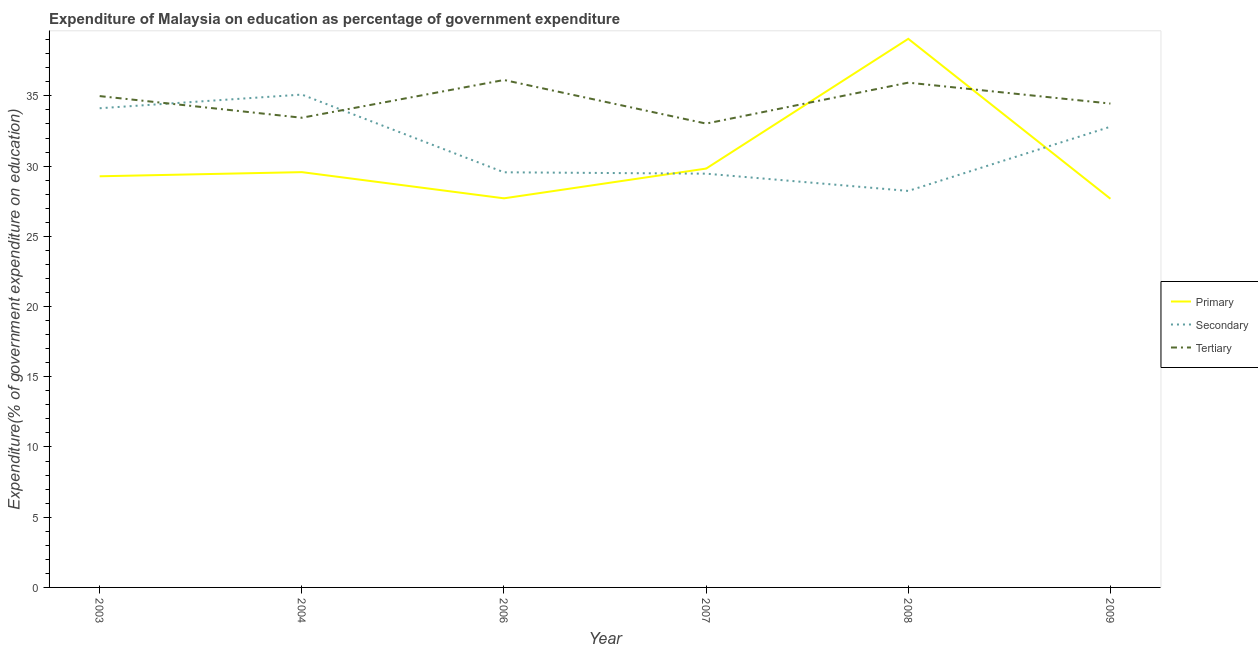Is the number of lines equal to the number of legend labels?
Give a very brief answer. Yes. What is the expenditure on secondary education in 2008?
Provide a short and direct response. 28.23. Across all years, what is the maximum expenditure on tertiary education?
Your answer should be very brief. 36.13. Across all years, what is the minimum expenditure on tertiary education?
Your answer should be compact. 33.03. In which year was the expenditure on tertiary education maximum?
Offer a very short reply. 2006. In which year was the expenditure on secondary education minimum?
Offer a terse response. 2008. What is the total expenditure on tertiary education in the graph?
Make the answer very short. 207.99. What is the difference between the expenditure on primary education in 2004 and that in 2007?
Your response must be concise. -0.25. What is the difference between the expenditure on tertiary education in 2007 and the expenditure on secondary education in 2009?
Offer a very short reply. 0.22. What is the average expenditure on primary education per year?
Keep it short and to the point. 30.52. In the year 2008, what is the difference between the expenditure on primary education and expenditure on secondary education?
Provide a succinct answer. 10.83. In how many years, is the expenditure on secondary education greater than 8 %?
Your response must be concise. 6. What is the ratio of the expenditure on tertiary education in 2003 to that in 2006?
Keep it short and to the point. 0.97. Is the expenditure on tertiary education in 2003 less than that in 2006?
Provide a short and direct response. Yes. Is the difference between the expenditure on tertiary education in 2007 and 2009 greater than the difference between the expenditure on secondary education in 2007 and 2009?
Keep it short and to the point. Yes. What is the difference between the highest and the second highest expenditure on tertiary education?
Provide a short and direct response. 0.19. What is the difference between the highest and the lowest expenditure on secondary education?
Give a very brief answer. 6.86. In how many years, is the expenditure on primary education greater than the average expenditure on primary education taken over all years?
Your answer should be very brief. 1. Is it the case that in every year, the sum of the expenditure on primary education and expenditure on secondary education is greater than the expenditure on tertiary education?
Ensure brevity in your answer.  Yes. Does the expenditure on primary education monotonically increase over the years?
Your answer should be very brief. No. Is the expenditure on primary education strictly less than the expenditure on secondary education over the years?
Give a very brief answer. No. Are the values on the major ticks of Y-axis written in scientific E-notation?
Make the answer very short. No. Does the graph contain any zero values?
Provide a succinct answer. No. Where does the legend appear in the graph?
Ensure brevity in your answer.  Center right. How are the legend labels stacked?
Provide a succinct answer. Vertical. What is the title of the graph?
Your answer should be very brief. Expenditure of Malaysia on education as percentage of government expenditure. What is the label or title of the X-axis?
Keep it short and to the point. Year. What is the label or title of the Y-axis?
Offer a very short reply. Expenditure(% of government expenditure on education). What is the Expenditure(% of government expenditure on education) in Primary in 2003?
Your answer should be very brief. 29.28. What is the Expenditure(% of government expenditure on education) in Secondary in 2003?
Ensure brevity in your answer.  34.12. What is the Expenditure(% of government expenditure on education) of Tertiary in 2003?
Your response must be concise. 34.99. What is the Expenditure(% of government expenditure on education) in Primary in 2004?
Make the answer very short. 29.57. What is the Expenditure(% of government expenditure on education) in Secondary in 2004?
Provide a succinct answer. 35.09. What is the Expenditure(% of government expenditure on education) in Tertiary in 2004?
Offer a very short reply. 33.45. What is the Expenditure(% of government expenditure on education) of Primary in 2006?
Ensure brevity in your answer.  27.71. What is the Expenditure(% of government expenditure on education) of Secondary in 2006?
Offer a terse response. 29.56. What is the Expenditure(% of government expenditure on education) of Tertiary in 2006?
Provide a succinct answer. 36.13. What is the Expenditure(% of government expenditure on education) of Primary in 2007?
Your response must be concise. 29.82. What is the Expenditure(% of government expenditure on education) in Secondary in 2007?
Your answer should be compact. 29.46. What is the Expenditure(% of government expenditure on education) of Tertiary in 2007?
Your answer should be very brief. 33.03. What is the Expenditure(% of government expenditure on education) in Primary in 2008?
Ensure brevity in your answer.  39.06. What is the Expenditure(% of government expenditure on education) of Secondary in 2008?
Provide a succinct answer. 28.23. What is the Expenditure(% of government expenditure on education) in Tertiary in 2008?
Give a very brief answer. 35.94. What is the Expenditure(% of government expenditure on education) of Primary in 2009?
Provide a short and direct response. 27.68. What is the Expenditure(% of government expenditure on education) of Secondary in 2009?
Your answer should be very brief. 32.81. What is the Expenditure(% of government expenditure on education) in Tertiary in 2009?
Offer a very short reply. 34.45. Across all years, what is the maximum Expenditure(% of government expenditure on education) in Primary?
Your answer should be compact. 39.06. Across all years, what is the maximum Expenditure(% of government expenditure on education) of Secondary?
Your answer should be compact. 35.09. Across all years, what is the maximum Expenditure(% of government expenditure on education) in Tertiary?
Provide a succinct answer. 36.13. Across all years, what is the minimum Expenditure(% of government expenditure on education) in Primary?
Provide a succinct answer. 27.68. Across all years, what is the minimum Expenditure(% of government expenditure on education) of Secondary?
Your response must be concise. 28.23. Across all years, what is the minimum Expenditure(% of government expenditure on education) in Tertiary?
Offer a very short reply. 33.03. What is the total Expenditure(% of government expenditure on education) of Primary in the graph?
Offer a terse response. 183.12. What is the total Expenditure(% of government expenditure on education) of Secondary in the graph?
Give a very brief answer. 189.28. What is the total Expenditure(% of government expenditure on education) in Tertiary in the graph?
Provide a succinct answer. 207.99. What is the difference between the Expenditure(% of government expenditure on education) of Primary in 2003 and that in 2004?
Provide a short and direct response. -0.3. What is the difference between the Expenditure(% of government expenditure on education) of Secondary in 2003 and that in 2004?
Your response must be concise. -0.97. What is the difference between the Expenditure(% of government expenditure on education) of Tertiary in 2003 and that in 2004?
Provide a short and direct response. 1.54. What is the difference between the Expenditure(% of government expenditure on education) of Primary in 2003 and that in 2006?
Your response must be concise. 1.57. What is the difference between the Expenditure(% of government expenditure on education) in Secondary in 2003 and that in 2006?
Offer a terse response. 4.56. What is the difference between the Expenditure(% of government expenditure on education) of Tertiary in 2003 and that in 2006?
Provide a short and direct response. -1.15. What is the difference between the Expenditure(% of government expenditure on education) of Primary in 2003 and that in 2007?
Make the answer very short. -0.55. What is the difference between the Expenditure(% of government expenditure on education) in Secondary in 2003 and that in 2007?
Offer a terse response. 4.66. What is the difference between the Expenditure(% of government expenditure on education) of Tertiary in 2003 and that in 2007?
Give a very brief answer. 1.96. What is the difference between the Expenditure(% of government expenditure on education) in Primary in 2003 and that in 2008?
Offer a terse response. -9.79. What is the difference between the Expenditure(% of government expenditure on education) in Secondary in 2003 and that in 2008?
Give a very brief answer. 5.89. What is the difference between the Expenditure(% of government expenditure on education) in Tertiary in 2003 and that in 2008?
Offer a terse response. -0.96. What is the difference between the Expenditure(% of government expenditure on education) in Primary in 2003 and that in 2009?
Ensure brevity in your answer.  1.6. What is the difference between the Expenditure(% of government expenditure on education) in Secondary in 2003 and that in 2009?
Ensure brevity in your answer.  1.32. What is the difference between the Expenditure(% of government expenditure on education) in Tertiary in 2003 and that in 2009?
Provide a succinct answer. 0.53. What is the difference between the Expenditure(% of government expenditure on education) of Primary in 2004 and that in 2006?
Offer a terse response. 1.86. What is the difference between the Expenditure(% of government expenditure on education) in Secondary in 2004 and that in 2006?
Make the answer very short. 5.53. What is the difference between the Expenditure(% of government expenditure on education) of Tertiary in 2004 and that in 2006?
Provide a succinct answer. -2.69. What is the difference between the Expenditure(% of government expenditure on education) in Primary in 2004 and that in 2007?
Make the answer very short. -0.25. What is the difference between the Expenditure(% of government expenditure on education) in Secondary in 2004 and that in 2007?
Offer a very short reply. 5.63. What is the difference between the Expenditure(% of government expenditure on education) of Tertiary in 2004 and that in 2007?
Give a very brief answer. 0.42. What is the difference between the Expenditure(% of government expenditure on education) of Primary in 2004 and that in 2008?
Give a very brief answer. -9.49. What is the difference between the Expenditure(% of government expenditure on education) of Secondary in 2004 and that in 2008?
Offer a terse response. 6.86. What is the difference between the Expenditure(% of government expenditure on education) in Tertiary in 2004 and that in 2008?
Offer a very short reply. -2.5. What is the difference between the Expenditure(% of government expenditure on education) of Primary in 2004 and that in 2009?
Make the answer very short. 1.9. What is the difference between the Expenditure(% of government expenditure on education) in Secondary in 2004 and that in 2009?
Provide a short and direct response. 2.29. What is the difference between the Expenditure(% of government expenditure on education) of Tertiary in 2004 and that in 2009?
Make the answer very short. -1.01. What is the difference between the Expenditure(% of government expenditure on education) of Primary in 2006 and that in 2007?
Give a very brief answer. -2.12. What is the difference between the Expenditure(% of government expenditure on education) of Secondary in 2006 and that in 2007?
Your answer should be compact. 0.1. What is the difference between the Expenditure(% of government expenditure on education) in Tertiary in 2006 and that in 2007?
Make the answer very short. 3.1. What is the difference between the Expenditure(% of government expenditure on education) of Primary in 2006 and that in 2008?
Provide a short and direct response. -11.36. What is the difference between the Expenditure(% of government expenditure on education) in Secondary in 2006 and that in 2008?
Provide a short and direct response. 1.33. What is the difference between the Expenditure(% of government expenditure on education) of Tertiary in 2006 and that in 2008?
Ensure brevity in your answer.  0.19. What is the difference between the Expenditure(% of government expenditure on education) of Primary in 2006 and that in 2009?
Your response must be concise. 0.03. What is the difference between the Expenditure(% of government expenditure on education) in Secondary in 2006 and that in 2009?
Your answer should be very brief. -3.25. What is the difference between the Expenditure(% of government expenditure on education) of Tertiary in 2006 and that in 2009?
Provide a short and direct response. 1.68. What is the difference between the Expenditure(% of government expenditure on education) in Primary in 2007 and that in 2008?
Keep it short and to the point. -9.24. What is the difference between the Expenditure(% of government expenditure on education) in Secondary in 2007 and that in 2008?
Ensure brevity in your answer.  1.23. What is the difference between the Expenditure(% of government expenditure on education) in Tertiary in 2007 and that in 2008?
Make the answer very short. -2.92. What is the difference between the Expenditure(% of government expenditure on education) in Primary in 2007 and that in 2009?
Keep it short and to the point. 2.15. What is the difference between the Expenditure(% of government expenditure on education) in Secondary in 2007 and that in 2009?
Provide a short and direct response. -3.34. What is the difference between the Expenditure(% of government expenditure on education) in Tertiary in 2007 and that in 2009?
Provide a succinct answer. -1.43. What is the difference between the Expenditure(% of government expenditure on education) in Primary in 2008 and that in 2009?
Provide a succinct answer. 11.39. What is the difference between the Expenditure(% of government expenditure on education) in Secondary in 2008 and that in 2009?
Provide a succinct answer. -4.57. What is the difference between the Expenditure(% of government expenditure on education) in Tertiary in 2008 and that in 2009?
Ensure brevity in your answer.  1.49. What is the difference between the Expenditure(% of government expenditure on education) of Primary in 2003 and the Expenditure(% of government expenditure on education) of Secondary in 2004?
Your answer should be compact. -5.82. What is the difference between the Expenditure(% of government expenditure on education) in Primary in 2003 and the Expenditure(% of government expenditure on education) in Tertiary in 2004?
Your response must be concise. -4.17. What is the difference between the Expenditure(% of government expenditure on education) of Secondary in 2003 and the Expenditure(% of government expenditure on education) of Tertiary in 2004?
Your response must be concise. 0.68. What is the difference between the Expenditure(% of government expenditure on education) in Primary in 2003 and the Expenditure(% of government expenditure on education) in Secondary in 2006?
Ensure brevity in your answer.  -0.28. What is the difference between the Expenditure(% of government expenditure on education) in Primary in 2003 and the Expenditure(% of government expenditure on education) in Tertiary in 2006?
Keep it short and to the point. -6.86. What is the difference between the Expenditure(% of government expenditure on education) of Secondary in 2003 and the Expenditure(% of government expenditure on education) of Tertiary in 2006?
Make the answer very short. -2.01. What is the difference between the Expenditure(% of government expenditure on education) in Primary in 2003 and the Expenditure(% of government expenditure on education) in Secondary in 2007?
Make the answer very short. -0.19. What is the difference between the Expenditure(% of government expenditure on education) in Primary in 2003 and the Expenditure(% of government expenditure on education) in Tertiary in 2007?
Provide a succinct answer. -3.75. What is the difference between the Expenditure(% of government expenditure on education) in Secondary in 2003 and the Expenditure(% of government expenditure on education) in Tertiary in 2007?
Keep it short and to the point. 1.09. What is the difference between the Expenditure(% of government expenditure on education) in Primary in 2003 and the Expenditure(% of government expenditure on education) in Secondary in 2008?
Give a very brief answer. 1.04. What is the difference between the Expenditure(% of government expenditure on education) of Primary in 2003 and the Expenditure(% of government expenditure on education) of Tertiary in 2008?
Ensure brevity in your answer.  -6.67. What is the difference between the Expenditure(% of government expenditure on education) of Secondary in 2003 and the Expenditure(% of government expenditure on education) of Tertiary in 2008?
Provide a succinct answer. -1.82. What is the difference between the Expenditure(% of government expenditure on education) in Primary in 2003 and the Expenditure(% of government expenditure on education) in Secondary in 2009?
Provide a succinct answer. -3.53. What is the difference between the Expenditure(% of government expenditure on education) of Primary in 2003 and the Expenditure(% of government expenditure on education) of Tertiary in 2009?
Your answer should be compact. -5.18. What is the difference between the Expenditure(% of government expenditure on education) in Secondary in 2003 and the Expenditure(% of government expenditure on education) in Tertiary in 2009?
Provide a succinct answer. -0.33. What is the difference between the Expenditure(% of government expenditure on education) in Primary in 2004 and the Expenditure(% of government expenditure on education) in Secondary in 2006?
Give a very brief answer. 0.01. What is the difference between the Expenditure(% of government expenditure on education) of Primary in 2004 and the Expenditure(% of government expenditure on education) of Tertiary in 2006?
Ensure brevity in your answer.  -6.56. What is the difference between the Expenditure(% of government expenditure on education) of Secondary in 2004 and the Expenditure(% of government expenditure on education) of Tertiary in 2006?
Ensure brevity in your answer.  -1.04. What is the difference between the Expenditure(% of government expenditure on education) in Primary in 2004 and the Expenditure(% of government expenditure on education) in Secondary in 2007?
Provide a short and direct response. 0.11. What is the difference between the Expenditure(% of government expenditure on education) in Primary in 2004 and the Expenditure(% of government expenditure on education) in Tertiary in 2007?
Provide a succinct answer. -3.46. What is the difference between the Expenditure(% of government expenditure on education) of Secondary in 2004 and the Expenditure(% of government expenditure on education) of Tertiary in 2007?
Your answer should be very brief. 2.07. What is the difference between the Expenditure(% of government expenditure on education) in Primary in 2004 and the Expenditure(% of government expenditure on education) in Secondary in 2008?
Your answer should be very brief. 1.34. What is the difference between the Expenditure(% of government expenditure on education) of Primary in 2004 and the Expenditure(% of government expenditure on education) of Tertiary in 2008?
Keep it short and to the point. -6.37. What is the difference between the Expenditure(% of government expenditure on education) of Secondary in 2004 and the Expenditure(% of government expenditure on education) of Tertiary in 2008?
Offer a very short reply. -0.85. What is the difference between the Expenditure(% of government expenditure on education) of Primary in 2004 and the Expenditure(% of government expenditure on education) of Secondary in 2009?
Your answer should be compact. -3.23. What is the difference between the Expenditure(% of government expenditure on education) in Primary in 2004 and the Expenditure(% of government expenditure on education) in Tertiary in 2009?
Make the answer very short. -4.88. What is the difference between the Expenditure(% of government expenditure on education) of Secondary in 2004 and the Expenditure(% of government expenditure on education) of Tertiary in 2009?
Keep it short and to the point. 0.64. What is the difference between the Expenditure(% of government expenditure on education) in Primary in 2006 and the Expenditure(% of government expenditure on education) in Secondary in 2007?
Your answer should be compact. -1.76. What is the difference between the Expenditure(% of government expenditure on education) of Primary in 2006 and the Expenditure(% of government expenditure on education) of Tertiary in 2007?
Ensure brevity in your answer.  -5.32. What is the difference between the Expenditure(% of government expenditure on education) of Secondary in 2006 and the Expenditure(% of government expenditure on education) of Tertiary in 2007?
Your answer should be compact. -3.47. What is the difference between the Expenditure(% of government expenditure on education) in Primary in 2006 and the Expenditure(% of government expenditure on education) in Secondary in 2008?
Make the answer very short. -0.53. What is the difference between the Expenditure(% of government expenditure on education) of Primary in 2006 and the Expenditure(% of government expenditure on education) of Tertiary in 2008?
Give a very brief answer. -8.24. What is the difference between the Expenditure(% of government expenditure on education) of Secondary in 2006 and the Expenditure(% of government expenditure on education) of Tertiary in 2008?
Provide a short and direct response. -6.38. What is the difference between the Expenditure(% of government expenditure on education) in Primary in 2006 and the Expenditure(% of government expenditure on education) in Secondary in 2009?
Provide a succinct answer. -5.1. What is the difference between the Expenditure(% of government expenditure on education) in Primary in 2006 and the Expenditure(% of government expenditure on education) in Tertiary in 2009?
Provide a succinct answer. -6.75. What is the difference between the Expenditure(% of government expenditure on education) of Secondary in 2006 and the Expenditure(% of government expenditure on education) of Tertiary in 2009?
Your answer should be compact. -4.89. What is the difference between the Expenditure(% of government expenditure on education) of Primary in 2007 and the Expenditure(% of government expenditure on education) of Secondary in 2008?
Give a very brief answer. 1.59. What is the difference between the Expenditure(% of government expenditure on education) of Primary in 2007 and the Expenditure(% of government expenditure on education) of Tertiary in 2008?
Offer a very short reply. -6.12. What is the difference between the Expenditure(% of government expenditure on education) in Secondary in 2007 and the Expenditure(% of government expenditure on education) in Tertiary in 2008?
Your answer should be very brief. -6.48. What is the difference between the Expenditure(% of government expenditure on education) of Primary in 2007 and the Expenditure(% of government expenditure on education) of Secondary in 2009?
Offer a terse response. -2.98. What is the difference between the Expenditure(% of government expenditure on education) in Primary in 2007 and the Expenditure(% of government expenditure on education) in Tertiary in 2009?
Your answer should be compact. -4.63. What is the difference between the Expenditure(% of government expenditure on education) of Secondary in 2007 and the Expenditure(% of government expenditure on education) of Tertiary in 2009?
Offer a very short reply. -4.99. What is the difference between the Expenditure(% of government expenditure on education) of Primary in 2008 and the Expenditure(% of government expenditure on education) of Secondary in 2009?
Offer a very short reply. 6.26. What is the difference between the Expenditure(% of government expenditure on education) in Primary in 2008 and the Expenditure(% of government expenditure on education) in Tertiary in 2009?
Ensure brevity in your answer.  4.61. What is the difference between the Expenditure(% of government expenditure on education) of Secondary in 2008 and the Expenditure(% of government expenditure on education) of Tertiary in 2009?
Your answer should be compact. -6.22. What is the average Expenditure(% of government expenditure on education) of Primary per year?
Offer a very short reply. 30.52. What is the average Expenditure(% of government expenditure on education) in Secondary per year?
Keep it short and to the point. 31.55. What is the average Expenditure(% of government expenditure on education) in Tertiary per year?
Your response must be concise. 34.67. In the year 2003, what is the difference between the Expenditure(% of government expenditure on education) of Primary and Expenditure(% of government expenditure on education) of Secondary?
Offer a terse response. -4.85. In the year 2003, what is the difference between the Expenditure(% of government expenditure on education) in Primary and Expenditure(% of government expenditure on education) in Tertiary?
Provide a succinct answer. -5.71. In the year 2003, what is the difference between the Expenditure(% of government expenditure on education) in Secondary and Expenditure(% of government expenditure on education) in Tertiary?
Give a very brief answer. -0.86. In the year 2004, what is the difference between the Expenditure(% of government expenditure on education) of Primary and Expenditure(% of government expenditure on education) of Secondary?
Your response must be concise. -5.52. In the year 2004, what is the difference between the Expenditure(% of government expenditure on education) of Primary and Expenditure(% of government expenditure on education) of Tertiary?
Keep it short and to the point. -3.87. In the year 2004, what is the difference between the Expenditure(% of government expenditure on education) in Secondary and Expenditure(% of government expenditure on education) in Tertiary?
Make the answer very short. 1.65. In the year 2006, what is the difference between the Expenditure(% of government expenditure on education) of Primary and Expenditure(% of government expenditure on education) of Secondary?
Provide a short and direct response. -1.85. In the year 2006, what is the difference between the Expenditure(% of government expenditure on education) in Primary and Expenditure(% of government expenditure on education) in Tertiary?
Offer a terse response. -8.43. In the year 2006, what is the difference between the Expenditure(% of government expenditure on education) of Secondary and Expenditure(% of government expenditure on education) of Tertiary?
Your answer should be compact. -6.57. In the year 2007, what is the difference between the Expenditure(% of government expenditure on education) of Primary and Expenditure(% of government expenditure on education) of Secondary?
Provide a succinct answer. 0.36. In the year 2007, what is the difference between the Expenditure(% of government expenditure on education) of Primary and Expenditure(% of government expenditure on education) of Tertiary?
Provide a short and direct response. -3.2. In the year 2007, what is the difference between the Expenditure(% of government expenditure on education) of Secondary and Expenditure(% of government expenditure on education) of Tertiary?
Provide a succinct answer. -3.57. In the year 2008, what is the difference between the Expenditure(% of government expenditure on education) of Primary and Expenditure(% of government expenditure on education) of Secondary?
Your response must be concise. 10.83. In the year 2008, what is the difference between the Expenditure(% of government expenditure on education) in Primary and Expenditure(% of government expenditure on education) in Tertiary?
Your answer should be very brief. 3.12. In the year 2008, what is the difference between the Expenditure(% of government expenditure on education) in Secondary and Expenditure(% of government expenditure on education) in Tertiary?
Your response must be concise. -7.71. In the year 2009, what is the difference between the Expenditure(% of government expenditure on education) of Primary and Expenditure(% of government expenditure on education) of Secondary?
Provide a succinct answer. -5.13. In the year 2009, what is the difference between the Expenditure(% of government expenditure on education) of Primary and Expenditure(% of government expenditure on education) of Tertiary?
Your answer should be very brief. -6.78. In the year 2009, what is the difference between the Expenditure(% of government expenditure on education) of Secondary and Expenditure(% of government expenditure on education) of Tertiary?
Your response must be concise. -1.65. What is the ratio of the Expenditure(% of government expenditure on education) in Primary in 2003 to that in 2004?
Ensure brevity in your answer.  0.99. What is the ratio of the Expenditure(% of government expenditure on education) in Secondary in 2003 to that in 2004?
Offer a terse response. 0.97. What is the ratio of the Expenditure(% of government expenditure on education) of Tertiary in 2003 to that in 2004?
Provide a short and direct response. 1.05. What is the ratio of the Expenditure(% of government expenditure on education) of Primary in 2003 to that in 2006?
Ensure brevity in your answer.  1.06. What is the ratio of the Expenditure(% of government expenditure on education) in Secondary in 2003 to that in 2006?
Offer a very short reply. 1.15. What is the ratio of the Expenditure(% of government expenditure on education) of Tertiary in 2003 to that in 2006?
Ensure brevity in your answer.  0.97. What is the ratio of the Expenditure(% of government expenditure on education) of Primary in 2003 to that in 2007?
Keep it short and to the point. 0.98. What is the ratio of the Expenditure(% of government expenditure on education) of Secondary in 2003 to that in 2007?
Offer a terse response. 1.16. What is the ratio of the Expenditure(% of government expenditure on education) of Tertiary in 2003 to that in 2007?
Make the answer very short. 1.06. What is the ratio of the Expenditure(% of government expenditure on education) in Primary in 2003 to that in 2008?
Offer a terse response. 0.75. What is the ratio of the Expenditure(% of government expenditure on education) of Secondary in 2003 to that in 2008?
Make the answer very short. 1.21. What is the ratio of the Expenditure(% of government expenditure on education) in Tertiary in 2003 to that in 2008?
Provide a succinct answer. 0.97. What is the ratio of the Expenditure(% of government expenditure on education) in Primary in 2003 to that in 2009?
Provide a succinct answer. 1.06. What is the ratio of the Expenditure(% of government expenditure on education) in Secondary in 2003 to that in 2009?
Provide a succinct answer. 1.04. What is the ratio of the Expenditure(% of government expenditure on education) in Tertiary in 2003 to that in 2009?
Your answer should be compact. 1.02. What is the ratio of the Expenditure(% of government expenditure on education) of Primary in 2004 to that in 2006?
Provide a succinct answer. 1.07. What is the ratio of the Expenditure(% of government expenditure on education) of Secondary in 2004 to that in 2006?
Provide a succinct answer. 1.19. What is the ratio of the Expenditure(% of government expenditure on education) in Tertiary in 2004 to that in 2006?
Offer a very short reply. 0.93. What is the ratio of the Expenditure(% of government expenditure on education) in Primary in 2004 to that in 2007?
Offer a terse response. 0.99. What is the ratio of the Expenditure(% of government expenditure on education) in Secondary in 2004 to that in 2007?
Your answer should be compact. 1.19. What is the ratio of the Expenditure(% of government expenditure on education) in Tertiary in 2004 to that in 2007?
Give a very brief answer. 1.01. What is the ratio of the Expenditure(% of government expenditure on education) of Primary in 2004 to that in 2008?
Keep it short and to the point. 0.76. What is the ratio of the Expenditure(% of government expenditure on education) in Secondary in 2004 to that in 2008?
Ensure brevity in your answer.  1.24. What is the ratio of the Expenditure(% of government expenditure on education) in Tertiary in 2004 to that in 2008?
Keep it short and to the point. 0.93. What is the ratio of the Expenditure(% of government expenditure on education) in Primary in 2004 to that in 2009?
Your answer should be compact. 1.07. What is the ratio of the Expenditure(% of government expenditure on education) of Secondary in 2004 to that in 2009?
Provide a succinct answer. 1.07. What is the ratio of the Expenditure(% of government expenditure on education) in Tertiary in 2004 to that in 2009?
Your answer should be very brief. 0.97. What is the ratio of the Expenditure(% of government expenditure on education) in Primary in 2006 to that in 2007?
Your response must be concise. 0.93. What is the ratio of the Expenditure(% of government expenditure on education) in Tertiary in 2006 to that in 2007?
Offer a terse response. 1.09. What is the ratio of the Expenditure(% of government expenditure on education) of Primary in 2006 to that in 2008?
Your answer should be very brief. 0.71. What is the ratio of the Expenditure(% of government expenditure on education) in Secondary in 2006 to that in 2008?
Your answer should be compact. 1.05. What is the ratio of the Expenditure(% of government expenditure on education) in Primary in 2006 to that in 2009?
Make the answer very short. 1. What is the ratio of the Expenditure(% of government expenditure on education) of Secondary in 2006 to that in 2009?
Provide a short and direct response. 0.9. What is the ratio of the Expenditure(% of government expenditure on education) in Tertiary in 2006 to that in 2009?
Provide a succinct answer. 1.05. What is the ratio of the Expenditure(% of government expenditure on education) of Primary in 2007 to that in 2008?
Keep it short and to the point. 0.76. What is the ratio of the Expenditure(% of government expenditure on education) of Secondary in 2007 to that in 2008?
Your answer should be compact. 1.04. What is the ratio of the Expenditure(% of government expenditure on education) in Tertiary in 2007 to that in 2008?
Provide a short and direct response. 0.92. What is the ratio of the Expenditure(% of government expenditure on education) in Primary in 2007 to that in 2009?
Offer a terse response. 1.08. What is the ratio of the Expenditure(% of government expenditure on education) of Secondary in 2007 to that in 2009?
Your answer should be compact. 0.9. What is the ratio of the Expenditure(% of government expenditure on education) in Tertiary in 2007 to that in 2009?
Provide a short and direct response. 0.96. What is the ratio of the Expenditure(% of government expenditure on education) of Primary in 2008 to that in 2009?
Provide a succinct answer. 1.41. What is the ratio of the Expenditure(% of government expenditure on education) in Secondary in 2008 to that in 2009?
Your answer should be very brief. 0.86. What is the ratio of the Expenditure(% of government expenditure on education) of Tertiary in 2008 to that in 2009?
Provide a short and direct response. 1.04. What is the difference between the highest and the second highest Expenditure(% of government expenditure on education) in Primary?
Your response must be concise. 9.24. What is the difference between the highest and the second highest Expenditure(% of government expenditure on education) in Secondary?
Ensure brevity in your answer.  0.97. What is the difference between the highest and the second highest Expenditure(% of government expenditure on education) of Tertiary?
Your answer should be compact. 0.19. What is the difference between the highest and the lowest Expenditure(% of government expenditure on education) of Primary?
Keep it short and to the point. 11.39. What is the difference between the highest and the lowest Expenditure(% of government expenditure on education) of Secondary?
Ensure brevity in your answer.  6.86. What is the difference between the highest and the lowest Expenditure(% of government expenditure on education) in Tertiary?
Ensure brevity in your answer.  3.1. 